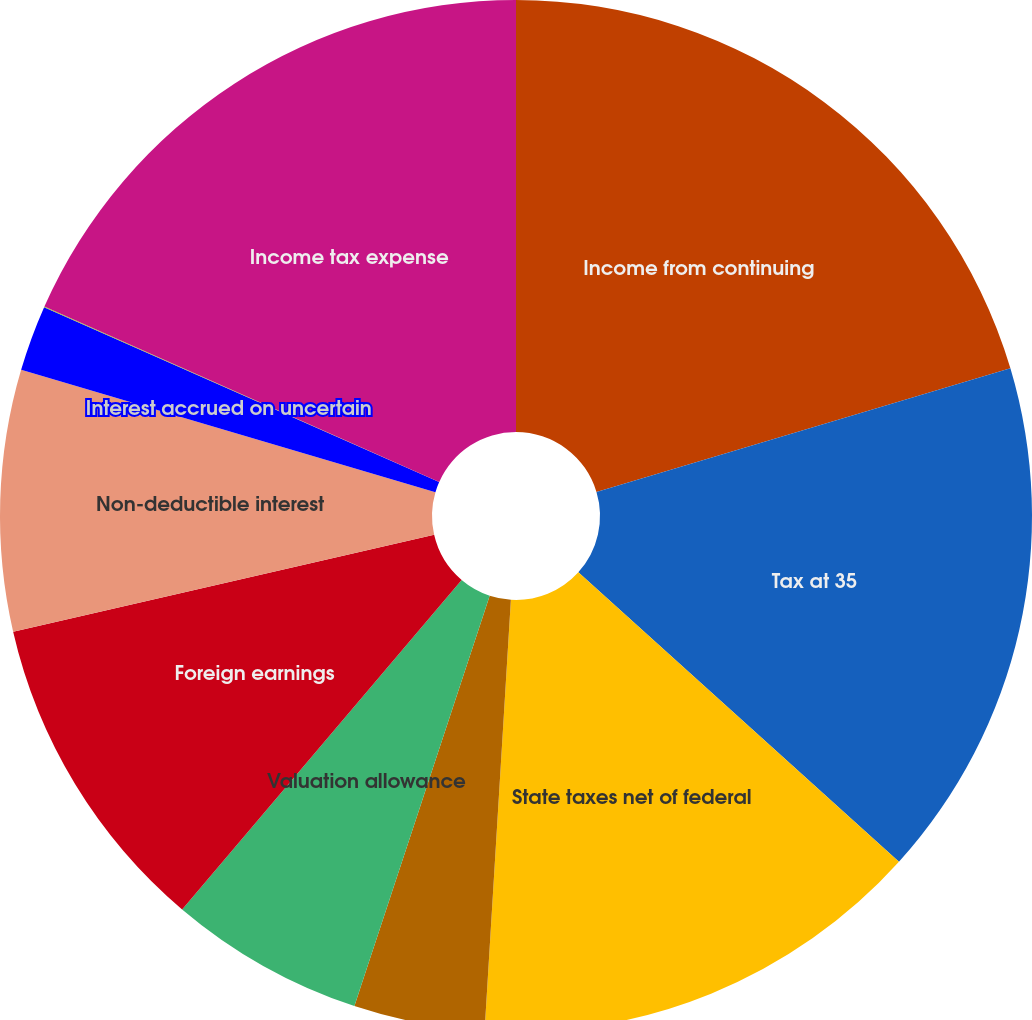<chart> <loc_0><loc_0><loc_500><loc_500><pie_chart><fcel>Income from continuing<fcel>Tax at 35<fcel>State taxes net of federal<fcel>Foreign operations<fcel>Valuation allowance<fcel>Foreign earnings<fcel>Non-deductible interest<fcel>Interest accrued on uncertain<fcel>Other<fcel>Income tax expense<nl><fcel>20.38%<fcel>16.31%<fcel>14.28%<fcel>4.1%<fcel>6.13%<fcel>10.2%<fcel>8.17%<fcel>2.06%<fcel>0.02%<fcel>18.35%<nl></chart> 